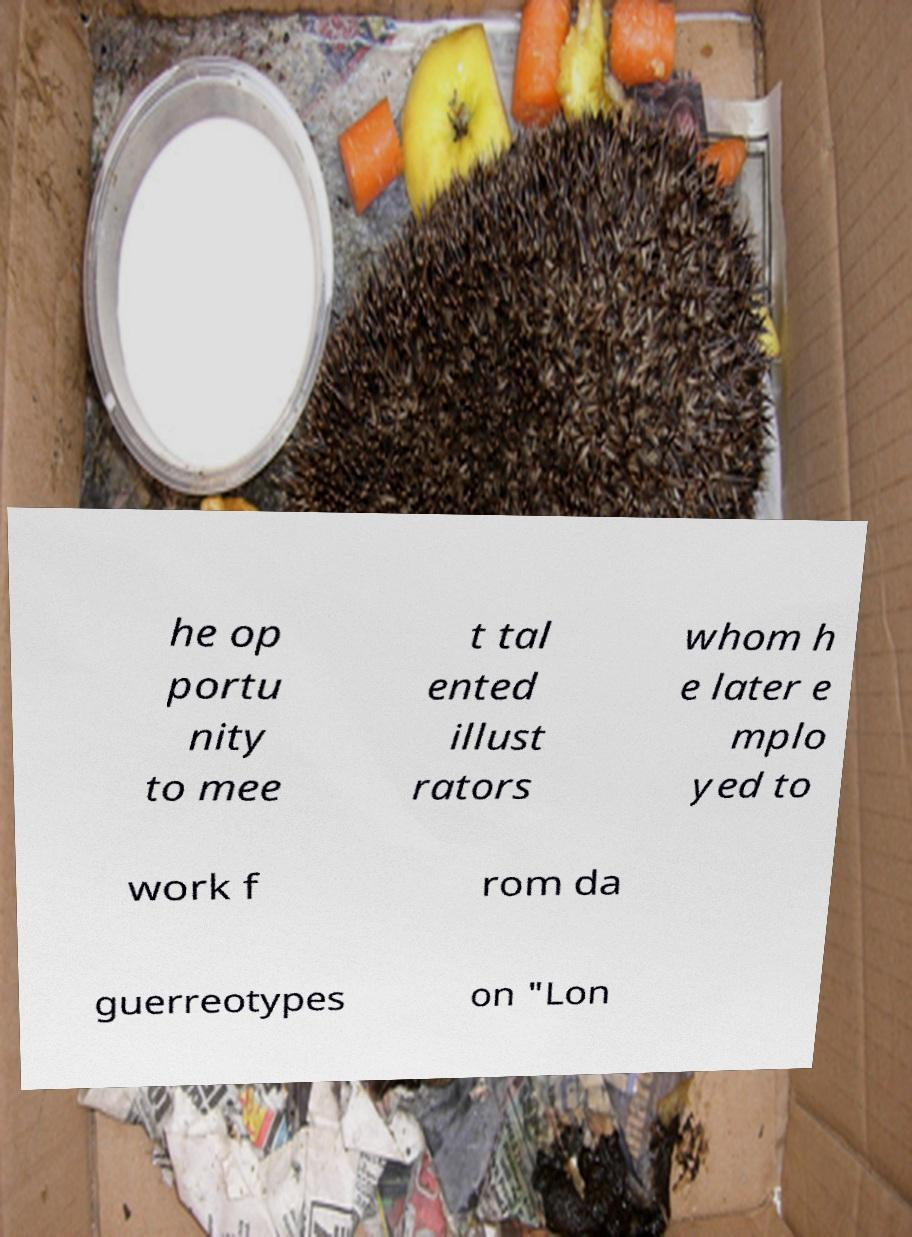For documentation purposes, I need the text within this image transcribed. Could you provide that? he op portu nity to mee t tal ented illust rators whom h e later e mplo yed to work f rom da guerreotypes on "Lon 